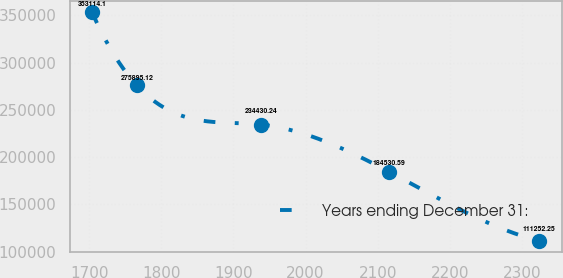Convert chart. <chart><loc_0><loc_0><loc_500><loc_500><line_chart><ecel><fcel>Years ending December 31:<nl><fcel>1704.09<fcel>353114<nl><fcel>1766.09<fcel>275895<nl><fcel>1938.63<fcel>234430<nl><fcel>2115.56<fcel>184531<nl><fcel>2324.14<fcel>111252<nl></chart> 